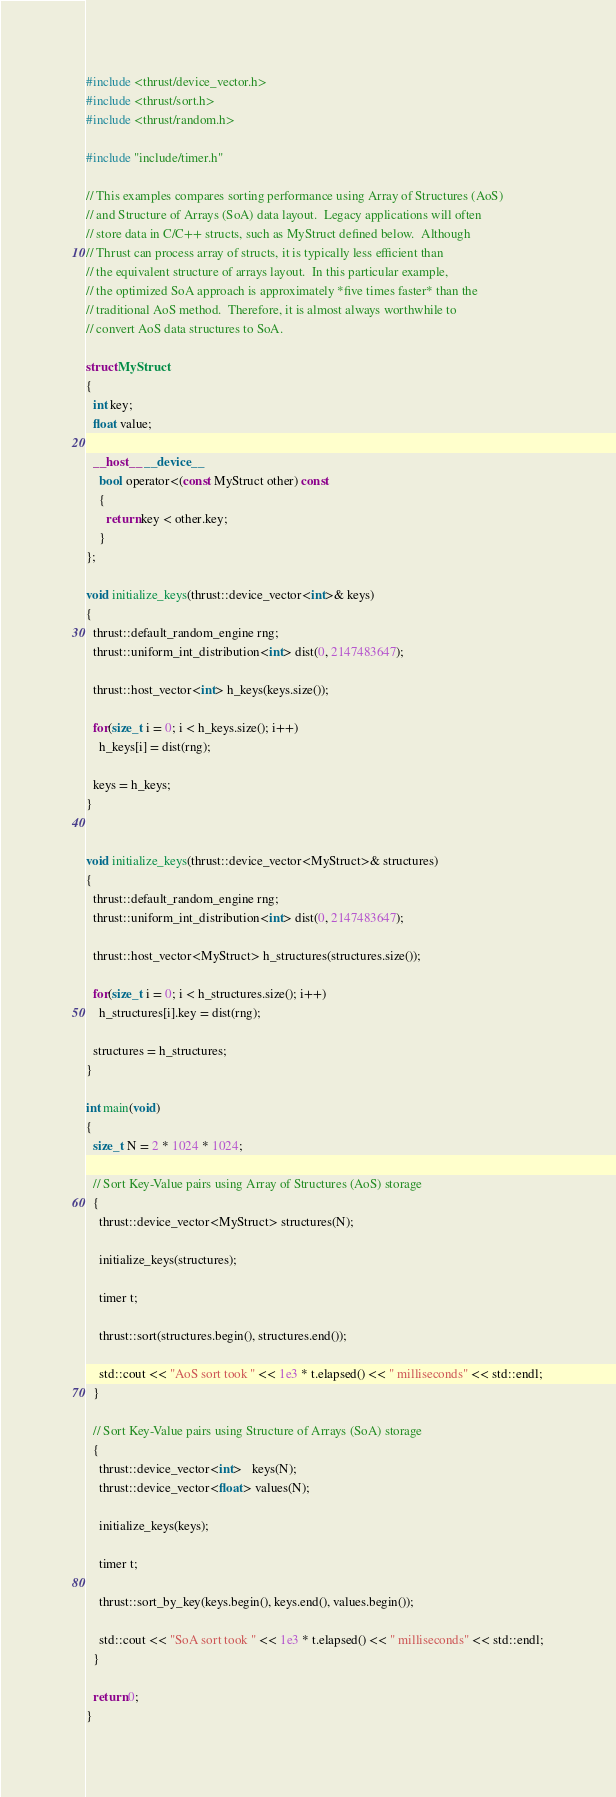Convert code to text. <code><loc_0><loc_0><loc_500><loc_500><_Cuda_>#include <thrust/device_vector.h>
#include <thrust/sort.h>
#include <thrust/random.h>

#include "include/timer.h"

// This examples compares sorting performance using Array of Structures (AoS)
// and Structure of Arrays (SoA) data layout.  Legacy applications will often
// store data in C/C++ structs, such as MyStruct defined below.  Although 
// Thrust can process array of structs, it is typically less efficient than
// the equivalent structure of arrays layout.  In this particular example,
// the optimized SoA approach is approximately *five times faster* than the
// traditional AoS method.  Therefore, it is almost always worthwhile to
// convert AoS data structures to SoA.

struct MyStruct
{
  int key;
  float value;

  __host__ __device__
    bool operator<(const MyStruct other) const
    {
      return key < other.key;
    }
};

void initialize_keys(thrust::device_vector<int>& keys)
{
  thrust::default_random_engine rng;
  thrust::uniform_int_distribution<int> dist(0, 2147483647);

  thrust::host_vector<int> h_keys(keys.size());

  for(size_t i = 0; i < h_keys.size(); i++)
    h_keys[i] = dist(rng);

  keys = h_keys;
}


void initialize_keys(thrust::device_vector<MyStruct>& structures)
{
  thrust::default_random_engine rng;
  thrust::uniform_int_distribution<int> dist(0, 2147483647);

  thrust::host_vector<MyStruct> h_structures(structures.size());

  for(size_t i = 0; i < h_structures.size(); i++)
    h_structures[i].key = dist(rng);

  structures = h_structures;
}

int main(void)
{
  size_t N = 2 * 1024 * 1024;

  // Sort Key-Value pairs using Array of Structures (AoS) storage 
  {
    thrust::device_vector<MyStruct> structures(N);

    initialize_keys(structures);

    timer t;

    thrust::sort(structures.begin(), structures.end());

    std::cout << "AoS sort took " << 1e3 * t.elapsed() << " milliseconds" << std::endl;
  }

  // Sort Key-Value pairs using Structure of Arrays (SoA) storage 
  {
    thrust::device_vector<int>   keys(N);
    thrust::device_vector<float> values(N);

    initialize_keys(keys);

    timer t;

    thrust::sort_by_key(keys.begin(), keys.end(), values.begin());

    std::cout << "SoA sort took " << 1e3 * t.elapsed() << " milliseconds" << std::endl;
  }

  return 0;
}

</code> 